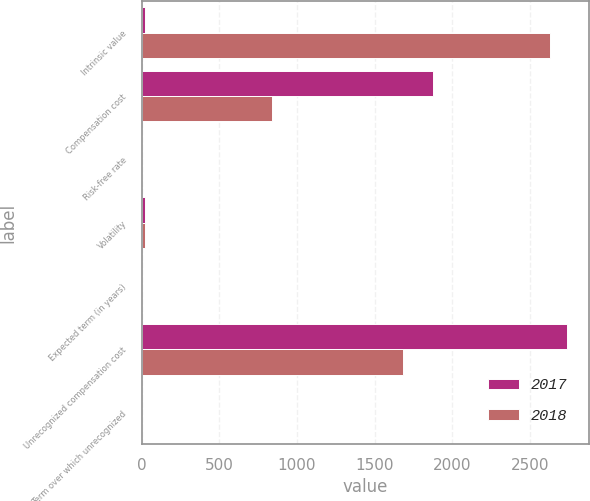Convert chart. <chart><loc_0><loc_0><loc_500><loc_500><stacked_bar_chart><ecel><fcel>Intrinsic value<fcel>Compensation cost<fcel>Risk-free rate<fcel>Volatility<fcel>Expected term (in years)<fcel>Unrecognized compensation cost<fcel>Term over which unrecognized<nl><fcel>2017<fcel>21.4<fcel>1873<fcel>2.37<fcel>22.6<fcel>2.9<fcel>2739<fcel>2<nl><fcel>2018<fcel>2630<fcel>840<fcel>1.62<fcel>21.4<fcel>2.8<fcel>1681<fcel>2<nl></chart> 